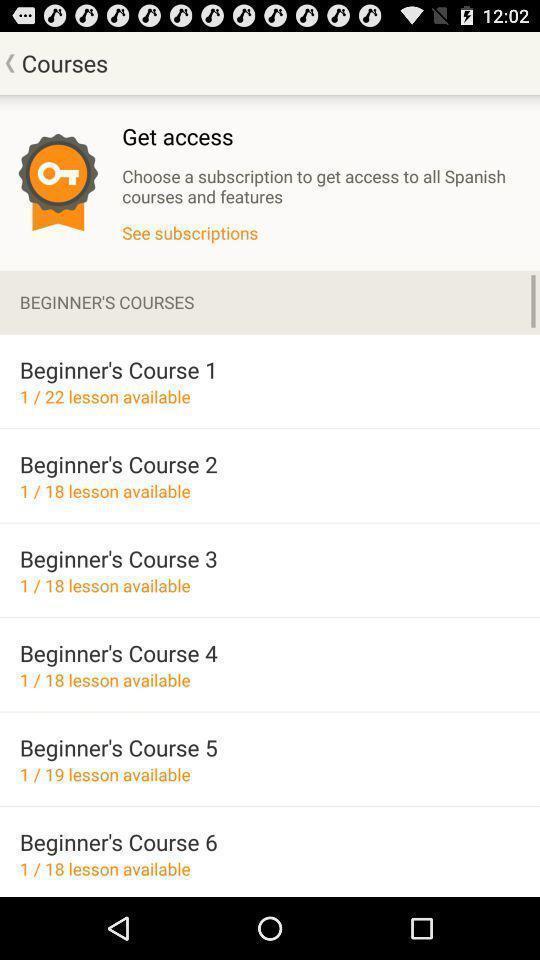What can you discern from this picture? Screen displaying the list of courses. 